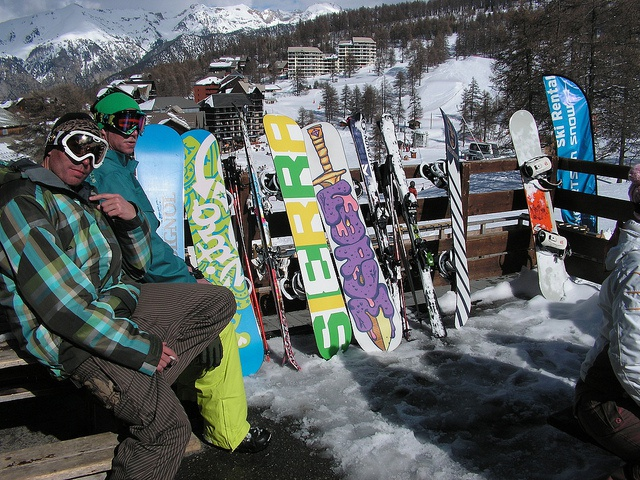Describe the objects in this image and their specific colors. I can see people in gray, black, and teal tones, people in gray, black, darkgray, and darkblue tones, snowboard in gray, violet, lightgray, and purple tones, snowboard in gray, lightgray, lightgreen, gold, and khaki tones, and snowboard in gray, lightgray, khaki, and lightblue tones in this image. 